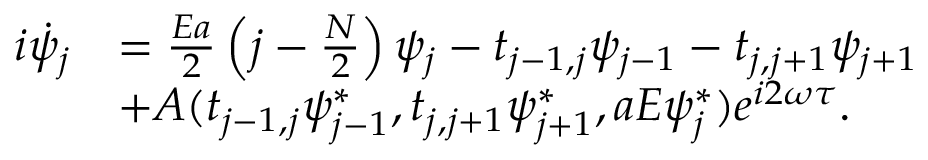Convert formula to latex. <formula><loc_0><loc_0><loc_500><loc_500>\begin{array} { r l } { i \dot { \psi } _ { j } } & { = \frac { E a } { 2 } \left ( j - \frac { N } { 2 } \right ) \psi _ { j } - t _ { j - 1 , j } \psi _ { j - 1 } - t _ { j , j + 1 } \psi _ { j + 1 } } \\ & { + A ( t _ { j - 1 , j } \psi _ { j - 1 } ^ { * } , t _ { j , j + 1 } \psi _ { j + 1 } ^ { * } , a E \psi _ { j } ^ { * } ) e ^ { i 2 \omega \tau } . } \end{array}</formula> 